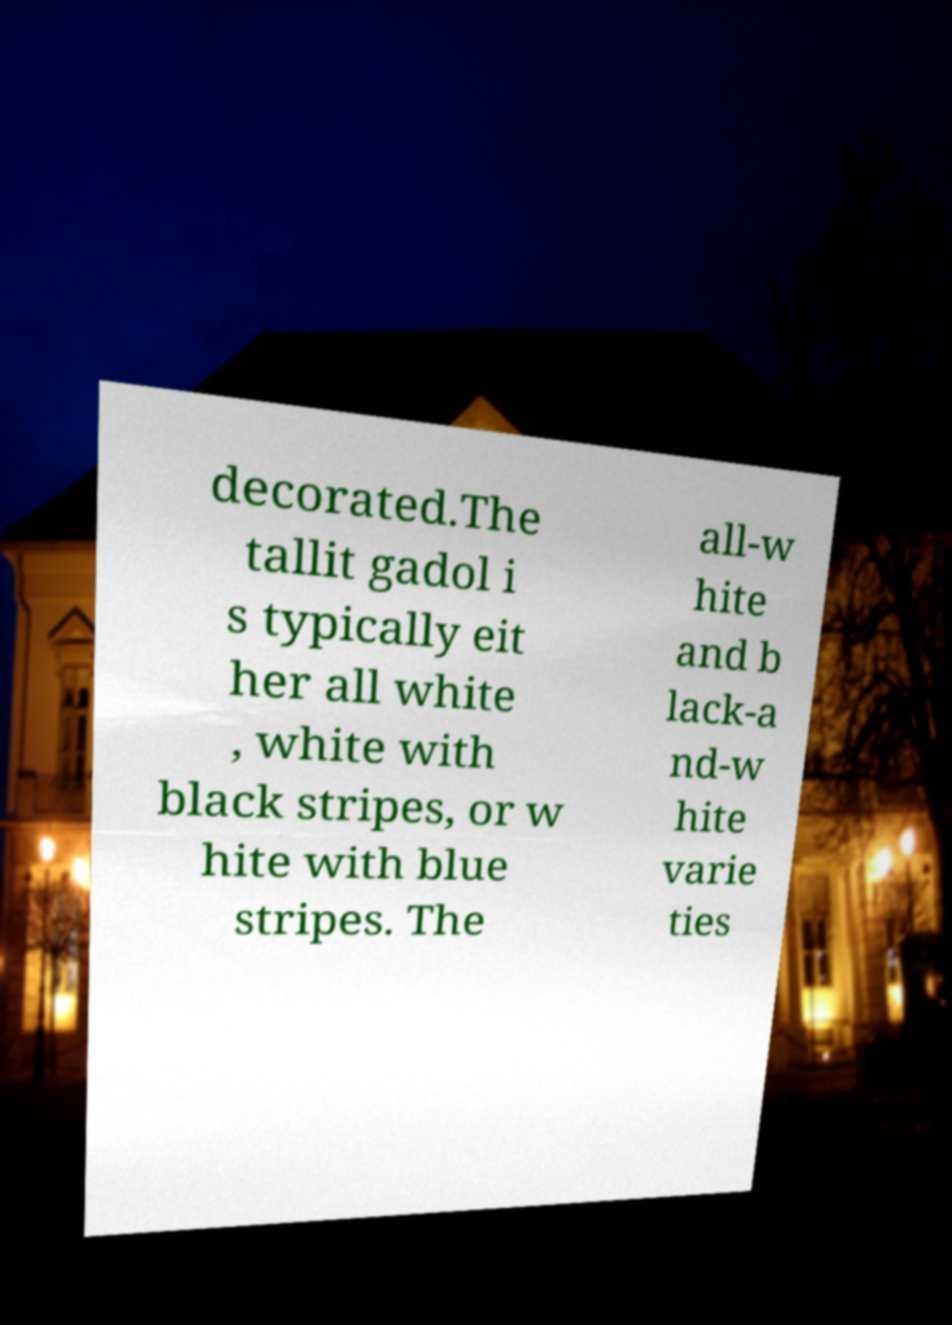Please identify and transcribe the text found in this image. decorated.The tallit gadol i s typically eit her all white , white with black stripes, or w hite with blue stripes. The all-w hite and b lack-a nd-w hite varie ties 